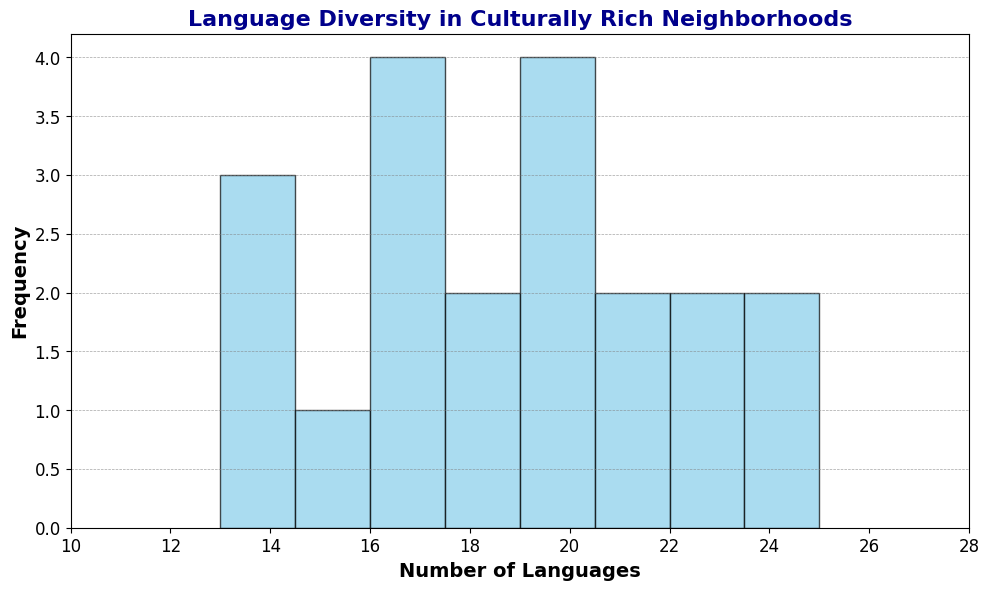How many neighborhoods have between 15 and 20 languages spoken? To answer this, count the frequency of bars in the histogram that fall within the 15 to 20 range.
Answer: 10 Which range of number of languages has the highest frequency of neighborhoods? Identify the tallest bar in the histogram and check the range it represents on the x-axis.
Answer: 15-17 Are there more neighborhoods with fewer than 15 languages or more than 21 languages? Count the frequencies of the bars to the left of 15 and to the right of 21, then compare.
Answer: Fewer than 15 languages What is the median number of languages spoken in these neighborhoods? Arrange the number of languages in ascending order and find the middle value. With 20 neighborhoods, the median is the average of the 10th and 11th values. The 10th value is 18 and the 11th value is 19. The median is (18+19)/2.
Answer: 18.5 How many neighborhoods have exactly 20 languages spoken? Check the frequency of the bar that represents the 20 languages category in the histogram.
Answer: 2 Is the average number of languages spoken in these neighborhoods higher than 18? Sum up all the numbers of languages and divide by the total number of neighborhoods (20). The sum is 358, so the average is 358/20.
Answer: Yes, it's 17.9 What is the total number of neighborhoods with languages between 13 and 17 inclusive? Add the frequencies of all the bars that fall within the 13 to 17 range.
Answer: 9 Compare neighborhoods with 14 languages and 21 languages; which group has more neighborhoods? Check the frequency of the bars that represent 14 and 21 languages and compare them.
Answer: 21 languages Which specific neighborhood has the highest language diversity? Look for the highest number on the histogram x-axis and identify the corresponding bar.
Answer: Hispanic District 